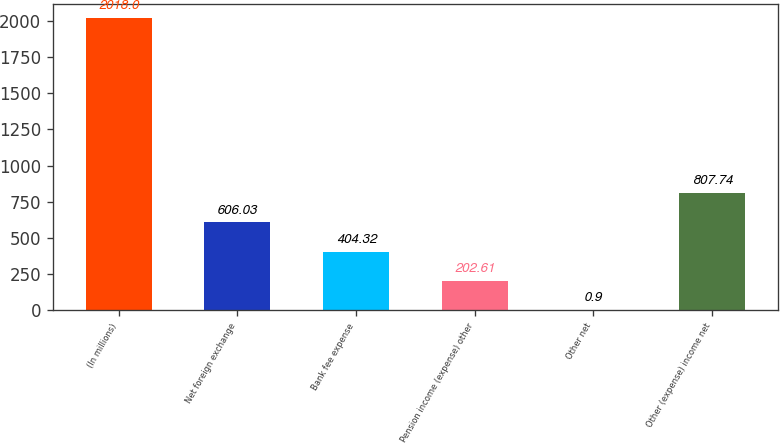<chart> <loc_0><loc_0><loc_500><loc_500><bar_chart><fcel>(In millions)<fcel>Net foreign exchange<fcel>Bank fee expense<fcel>Pension income (expense) other<fcel>Other net<fcel>Other (expense) income net<nl><fcel>2018<fcel>606.03<fcel>404.32<fcel>202.61<fcel>0.9<fcel>807.74<nl></chart> 